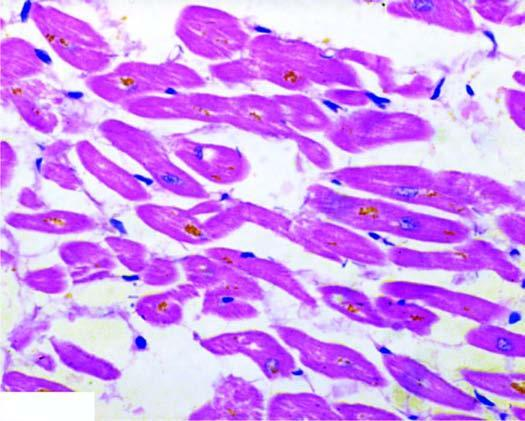re others seen in the cytoplasm of the myocardial fibres, especially around the nuclei?
Answer the question using a single word or phrase. No 